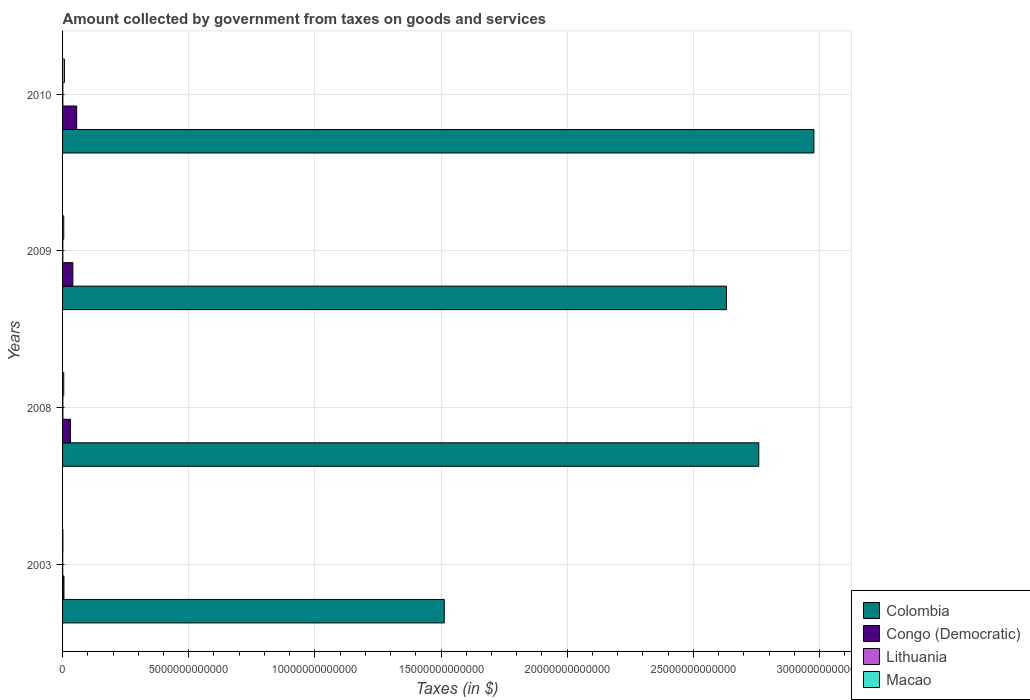Are the number of bars on each tick of the Y-axis equal?
Give a very brief answer. Yes. How many bars are there on the 3rd tick from the top?
Keep it short and to the point. 4. How many bars are there on the 2nd tick from the bottom?
Provide a succinct answer. 4. What is the label of the 1st group of bars from the top?
Provide a short and direct response. 2010. In how many cases, is the number of bars for a given year not equal to the number of legend labels?
Your answer should be compact. 0. What is the amount collected by government from taxes on goods and services in Colombia in 2010?
Offer a terse response. 2.98e+13. Across all years, what is the maximum amount collected by government from taxes on goods and services in Colombia?
Keep it short and to the point. 2.98e+13. Across all years, what is the minimum amount collected by government from taxes on goods and services in Colombia?
Your response must be concise. 1.51e+13. In which year was the amount collected by government from taxes on goods and services in Congo (Democratic) minimum?
Your answer should be compact. 2003. What is the total amount collected by government from taxes on goods and services in Lithuania in the graph?
Make the answer very short. 3.94e+1. What is the difference between the amount collected by government from taxes on goods and services in Congo (Democratic) in 2003 and that in 2010?
Offer a very short reply. -5.03e+11. What is the difference between the amount collected by government from taxes on goods and services in Colombia in 2010 and the amount collected by government from taxes on goods and services in Macao in 2008?
Provide a succinct answer. 2.97e+13. What is the average amount collected by government from taxes on goods and services in Macao per year?
Offer a very short reply. 4.46e+1. In the year 2010, what is the difference between the amount collected by government from taxes on goods and services in Lithuania and amount collected by government from taxes on goods and services in Congo (Democratic)?
Provide a short and direct response. -5.49e+11. What is the ratio of the amount collected by government from taxes on goods and services in Macao in 2003 to that in 2008?
Your response must be concise. 0.25. Is the difference between the amount collected by government from taxes on goods and services in Lithuania in 2008 and 2009 greater than the difference between the amount collected by government from taxes on goods and services in Congo (Democratic) in 2008 and 2009?
Offer a very short reply. Yes. What is the difference between the highest and the second highest amount collected by government from taxes on goods and services in Lithuania?
Offer a very short reply. 1.60e+09. What is the difference between the highest and the lowest amount collected by government from taxes on goods and services in Macao?
Ensure brevity in your answer.  6.15e+1. Is it the case that in every year, the sum of the amount collected by government from taxes on goods and services in Macao and amount collected by government from taxes on goods and services in Colombia is greater than the sum of amount collected by government from taxes on goods and services in Lithuania and amount collected by government from taxes on goods and services in Congo (Democratic)?
Make the answer very short. Yes. What does the 4th bar from the top in 2009 represents?
Make the answer very short. Colombia. Are all the bars in the graph horizontal?
Give a very brief answer. Yes. How many years are there in the graph?
Ensure brevity in your answer.  4. What is the difference between two consecutive major ticks on the X-axis?
Give a very brief answer. 5.00e+12. Does the graph contain any zero values?
Your answer should be compact. No. Does the graph contain grids?
Ensure brevity in your answer.  Yes. What is the title of the graph?
Give a very brief answer. Amount collected by government from taxes on goods and services. What is the label or title of the X-axis?
Provide a succinct answer. Taxes (in $). What is the label or title of the Y-axis?
Give a very brief answer. Years. What is the Taxes (in $) in Colombia in 2003?
Make the answer very short. 1.51e+13. What is the Taxes (in $) in Congo (Democratic) in 2003?
Give a very brief answer. 5.59e+1. What is the Taxes (in $) in Lithuania in 2003?
Make the answer very short. 6.27e+09. What is the Taxes (in $) of Macao in 2003?
Offer a terse response. 1.17e+1. What is the Taxes (in $) of Colombia in 2008?
Make the answer very short. 2.76e+13. What is the Taxes (in $) of Congo (Democratic) in 2008?
Keep it short and to the point. 3.13e+11. What is the Taxes (in $) in Lithuania in 2008?
Provide a short and direct response. 1.24e+1. What is the Taxes (in $) of Macao in 2008?
Give a very brief answer. 4.68e+1. What is the Taxes (in $) of Colombia in 2009?
Offer a terse response. 2.63e+13. What is the Taxes (in $) of Congo (Democratic) in 2009?
Your response must be concise. 4.07e+11. What is the Taxes (in $) of Lithuania in 2009?
Provide a short and direct response. 1.00e+1. What is the Taxes (in $) in Macao in 2009?
Your response must be concise. 4.67e+1. What is the Taxes (in $) of Colombia in 2010?
Offer a very short reply. 2.98e+13. What is the Taxes (in $) in Congo (Democratic) in 2010?
Your answer should be very brief. 5.59e+11. What is the Taxes (in $) of Lithuania in 2010?
Offer a very short reply. 1.08e+1. What is the Taxes (in $) of Macao in 2010?
Provide a succinct answer. 7.32e+1. Across all years, what is the maximum Taxes (in $) in Colombia?
Provide a short and direct response. 2.98e+13. Across all years, what is the maximum Taxes (in $) of Congo (Democratic)?
Offer a terse response. 5.59e+11. Across all years, what is the maximum Taxes (in $) of Lithuania?
Offer a very short reply. 1.24e+1. Across all years, what is the maximum Taxes (in $) of Macao?
Give a very brief answer. 7.32e+1. Across all years, what is the minimum Taxes (in $) in Colombia?
Make the answer very short. 1.51e+13. Across all years, what is the minimum Taxes (in $) in Congo (Democratic)?
Your answer should be very brief. 5.59e+1. Across all years, what is the minimum Taxes (in $) in Lithuania?
Give a very brief answer. 6.27e+09. Across all years, what is the minimum Taxes (in $) of Macao?
Ensure brevity in your answer.  1.17e+1. What is the total Taxes (in $) of Colombia in the graph?
Offer a very short reply. 9.88e+13. What is the total Taxes (in $) of Congo (Democratic) in the graph?
Make the answer very short. 1.34e+12. What is the total Taxes (in $) of Lithuania in the graph?
Your response must be concise. 3.94e+1. What is the total Taxes (in $) in Macao in the graph?
Provide a succinct answer. 1.78e+11. What is the difference between the Taxes (in $) of Colombia in 2003 and that in 2008?
Give a very brief answer. -1.25e+13. What is the difference between the Taxes (in $) of Congo (Democratic) in 2003 and that in 2008?
Give a very brief answer. -2.57e+11. What is the difference between the Taxes (in $) in Lithuania in 2003 and that in 2008?
Ensure brevity in your answer.  -6.09e+09. What is the difference between the Taxes (in $) in Macao in 2003 and that in 2008?
Your response must be concise. -3.51e+1. What is the difference between the Taxes (in $) in Colombia in 2003 and that in 2009?
Give a very brief answer. -1.12e+13. What is the difference between the Taxes (in $) in Congo (Democratic) in 2003 and that in 2009?
Offer a terse response. -3.51e+11. What is the difference between the Taxes (in $) in Lithuania in 2003 and that in 2009?
Keep it short and to the point. -3.77e+09. What is the difference between the Taxes (in $) in Macao in 2003 and that in 2009?
Offer a terse response. -3.50e+1. What is the difference between the Taxes (in $) in Colombia in 2003 and that in 2010?
Ensure brevity in your answer.  -1.47e+13. What is the difference between the Taxes (in $) in Congo (Democratic) in 2003 and that in 2010?
Your answer should be very brief. -5.03e+11. What is the difference between the Taxes (in $) in Lithuania in 2003 and that in 2010?
Offer a very short reply. -4.48e+09. What is the difference between the Taxes (in $) in Macao in 2003 and that in 2010?
Your response must be concise. -6.15e+1. What is the difference between the Taxes (in $) of Colombia in 2008 and that in 2009?
Keep it short and to the point. 1.28e+12. What is the difference between the Taxes (in $) in Congo (Democratic) in 2008 and that in 2009?
Provide a succinct answer. -9.42e+1. What is the difference between the Taxes (in $) in Lithuania in 2008 and that in 2009?
Make the answer very short. 2.31e+09. What is the difference between the Taxes (in $) in Macao in 2008 and that in 2009?
Offer a terse response. 8.05e+07. What is the difference between the Taxes (in $) in Colombia in 2008 and that in 2010?
Offer a terse response. -2.18e+12. What is the difference between the Taxes (in $) of Congo (Democratic) in 2008 and that in 2010?
Your answer should be compact. -2.46e+11. What is the difference between the Taxes (in $) in Lithuania in 2008 and that in 2010?
Your answer should be compact. 1.60e+09. What is the difference between the Taxes (in $) of Macao in 2008 and that in 2010?
Make the answer very short. -2.64e+1. What is the difference between the Taxes (in $) in Colombia in 2009 and that in 2010?
Provide a succinct answer. -3.47e+12. What is the difference between the Taxes (in $) of Congo (Democratic) in 2009 and that in 2010?
Provide a succinct answer. -1.52e+11. What is the difference between the Taxes (in $) in Lithuania in 2009 and that in 2010?
Make the answer very short. -7.11e+08. What is the difference between the Taxes (in $) in Macao in 2009 and that in 2010?
Provide a short and direct response. -2.64e+1. What is the difference between the Taxes (in $) of Colombia in 2003 and the Taxes (in $) of Congo (Democratic) in 2008?
Offer a terse response. 1.48e+13. What is the difference between the Taxes (in $) in Colombia in 2003 and the Taxes (in $) in Lithuania in 2008?
Provide a succinct answer. 1.51e+13. What is the difference between the Taxes (in $) in Colombia in 2003 and the Taxes (in $) in Macao in 2008?
Ensure brevity in your answer.  1.51e+13. What is the difference between the Taxes (in $) of Congo (Democratic) in 2003 and the Taxes (in $) of Lithuania in 2008?
Ensure brevity in your answer.  4.35e+1. What is the difference between the Taxes (in $) of Congo (Democratic) in 2003 and the Taxes (in $) of Macao in 2008?
Your answer should be very brief. 9.08e+09. What is the difference between the Taxes (in $) in Lithuania in 2003 and the Taxes (in $) in Macao in 2008?
Your response must be concise. -4.06e+1. What is the difference between the Taxes (in $) of Colombia in 2003 and the Taxes (in $) of Congo (Democratic) in 2009?
Provide a succinct answer. 1.47e+13. What is the difference between the Taxes (in $) in Colombia in 2003 and the Taxes (in $) in Lithuania in 2009?
Offer a very short reply. 1.51e+13. What is the difference between the Taxes (in $) in Colombia in 2003 and the Taxes (in $) in Macao in 2009?
Your answer should be compact. 1.51e+13. What is the difference between the Taxes (in $) of Congo (Democratic) in 2003 and the Taxes (in $) of Lithuania in 2009?
Ensure brevity in your answer.  4.59e+1. What is the difference between the Taxes (in $) in Congo (Democratic) in 2003 and the Taxes (in $) in Macao in 2009?
Ensure brevity in your answer.  9.16e+09. What is the difference between the Taxes (in $) of Lithuania in 2003 and the Taxes (in $) of Macao in 2009?
Make the answer very short. -4.05e+1. What is the difference between the Taxes (in $) of Colombia in 2003 and the Taxes (in $) of Congo (Democratic) in 2010?
Make the answer very short. 1.46e+13. What is the difference between the Taxes (in $) of Colombia in 2003 and the Taxes (in $) of Lithuania in 2010?
Your response must be concise. 1.51e+13. What is the difference between the Taxes (in $) of Colombia in 2003 and the Taxes (in $) of Macao in 2010?
Keep it short and to the point. 1.51e+13. What is the difference between the Taxes (in $) in Congo (Democratic) in 2003 and the Taxes (in $) in Lithuania in 2010?
Offer a very short reply. 4.52e+1. What is the difference between the Taxes (in $) in Congo (Democratic) in 2003 and the Taxes (in $) in Macao in 2010?
Offer a terse response. -1.73e+1. What is the difference between the Taxes (in $) of Lithuania in 2003 and the Taxes (in $) of Macao in 2010?
Ensure brevity in your answer.  -6.69e+1. What is the difference between the Taxes (in $) in Colombia in 2008 and the Taxes (in $) in Congo (Democratic) in 2009?
Give a very brief answer. 2.72e+13. What is the difference between the Taxes (in $) of Colombia in 2008 and the Taxes (in $) of Lithuania in 2009?
Give a very brief answer. 2.76e+13. What is the difference between the Taxes (in $) of Colombia in 2008 and the Taxes (in $) of Macao in 2009?
Your answer should be very brief. 2.75e+13. What is the difference between the Taxes (in $) of Congo (Democratic) in 2008 and the Taxes (in $) of Lithuania in 2009?
Your answer should be very brief. 3.03e+11. What is the difference between the Taxes (in $) of Congo (Democratic) in 2008 and the Taxes (in $) of Macao in 2009?
Ensure brevity in your answer.  2.66e+11. What is the difference between the Taxes (in $) in Lithuania in 2008 and the Taxes (in $) in Macao in 2009?
Offer a terse response. -3.44e+1. What is the difference between the Taxes (in $) in Colombia in 2008 and the Taxes (in $) in Congo (Democratic) in 2010?
Provide a short and direct response. 2.70e+13. What is the difference between the Taxes (in $) of Colombia in 2008 and the Taxes (in $) of Lithuania in 2010?
Provide a short and direct response. 2.76e+13. What is the difference between the Taxes (in $) of Colombia in 2008 and the Taxes (in $) of Macao in 2010?
Make the answer very short. 2.75e+13. What is the difference between the Taxes (in $) in Congo (Democratic) in 2008 and the Taxes (in $) in Lithuania in 2010?
Provide a succinct answer. 3.02e+11. What is the difference between the Taxes (in $) of Congo (Democratic) in 2008 and the Taxes (in $) of Macao in 2010?
Provide a short and direct response. 2.40e+11. What is the difference between the Taxes (in $) in Lithuania in 2008 and the Taxes (in $) in Macao in 2010?
Provide a short and direct response. -6.08e+1. What is the difference between the Taxes (in $) in Colombia in 2009 and the Taxes (in $) in Congo (Democratic) in 2010?
Your answer should be very brief. 2.58e+13. What is the difference between the Taxes (in $) in Colombia in 2009 and the Taxes (in $) in Lithuania in 2010?
Provide a short and direct response. 2.63e+13. What is the difference between the Taxes (in $) of Colombia in 2009 and the Taxes (in $) of Macao in 2010?
Provide a succinct answer. 2.62e+13. What is the difference between the Taxes (in $) in Congo (Democratic) in 2009 and the Taxes (in $) in Lithuania in 2010?
Your response must be concise. 3.96e+11. What is the difference between the Taxes (in $) of Congo (Democratic) in 2009 and the Taxes (in $) of Macao in 2010?
Your answer should be compact. 3.34e+11. What is the difference between the Taxes (in $) of Lithuania in 2009 and the Taxes (in $) of Macao in 2010?
Offer a terse response. -6.31e+1. What is the average Taxes (in $) of Colombia per year?
Your answer should be compact. 2.47e+13. What is the average Taxes (in $) of Congo (Democratic) per year?
Your response must be concise. 3.34e+11. What is the average Taxes (in $) of Lithuania per year?
Ensure brevity in your answer.  9.86e+09. What is the average Taxes (in $) of Macao per year?
Your response must be concise. 4.46e+1. In the year 2003, what is the difference between the Taxes (in $) of Colombia and Taxes (in $) of Congo (Democratic)?
Provide a succinct answer. 1.51e+13. In the year 2003, what is the difference between the Taxes (in $) of Colombia and Taxes (in $) of Lithuania?
Make the answer very short. 1.51e+13. In the year 2003, what is the difference between the Taxes (in $) in Colombia and Taxes (in $) in Macao?
Make the answer very short. 1.51e+13. In the year 2003, what is the difference between the Taxes (in $) of Congo (Democratic) and Taxes (in $) of Lithuania?
Ensure brevity in your answer.  4.96e+1. In the year 2003, what is the difference between the Taxes (in $) in Congo (Democratic) and Taxes (in $) in Macao?
Provide a short and direct response. 4.42e+1. In the year 2003, what is the difference between the Taxes (in $) of Lithuania and Taxes (in $) of Macao?
Your response must be concise. -5.46e+09. In the year 2008, what is the difference between the Taxes (in $) of Colombia and Taxes (in $) of Congo (Democratic)?
Your answer should be very brief. 2.73e+13. In the year 2008, what is the difference between the Taxes (in $) in Colombia and Taxes (in $) in Lithuania?
Offer a very short reply. 2.76e+13. In the year 2008, what is the difference between the Taxes (in $) in Colombia and Taxes (in $) in Macao?
Keep it short and to the point. 2.75e+13. In the year 2008, what is the difference between the Taxes (in $) of Congo (Democratic) and Taxes (in $) of Lithuania?
Provide a succinct answer. 3.01e+11. In the year 2008, what is the difference between the Taxes (in $) in Congo (Democratic) and Taxes (in $) in Macao?
Your answer should be very brief. 2.66e+11. In the year 2008, what is the difference between the Taxes (in $) of Lithuania and Taxes (in $) of Macao?
Keep it short and to the point. -3.45e+1. In the year 2009, what is the difference between the Taxes (in $) in Colombia and Taxes (in $) in Congo (Democratic)?
Offer a very short reply. 2.59e+13. In the year 2009, what is the difference between the Taxes (in $) of Colombia and Taxes (in $) of Lithuania?
Give a very brief answer. 2.63e+13. In the year 2009, what is the difference between the Taxes (in $) of Colombia and Taxes (in $) of Macao?
Provide a short and direct response. 2.63e+13. In the year 2009, what is the difference between the Taxes (in $) of Congo (Democratic) and Taxes (in $) of Lithuania?
Make the answer very short. 3.97e+11. In the year 2009, what is the difference between the Taxes (in $) in Congo (Democratic) and Taxes (in $) in Macao?
Your response must be concise. 3.60e+11. In the year 2009, what is the difference between the Taxes (in $) in Lithuania and Taxes (in $) in Macao?
Offer a very short reply. -3.67e+1. In the year 2010, what is the difference between the Taxes (in $) in Colombia and Taxes (in $) in Congo (Democratic)?
Keep it short and to the point. 2.92e+13. In the year 2010, what is the difference between the Taxes (in $) of Colombia and Taxes (in $) of Lithuania?
Ensure brevity in your answer.  2.98e+13. In the year 2010, what is the difference between the Taxes (in $) in Colombia and Taxes (in $) in Macao?
Your answer should be very brief. 2.97e+13. In the year 2010, what is the difference between the Taxes (in $) of Congo (Democratic) and Taxes (in $) of Lithuania?
Your answer should be very brief. 5.49e+11. In the year 2010, what is the difference between the Taxes (in $) in Congo (Democratic) and Taxes (in $) in Macao?
Your answer should be compact. 4.86e+11. In the year 2010, what is the difference between the Taxes (in $) in Lithuania and Taxes (in $) in Macao?
Offer a very short reply. -6.24e+1. What is the ratio of the Taxes (in $) in Colombia in 2003 to that in 2008?
Your answer should be compact. 0.55. What is the ratio of the Taxes (in $) in Congo (Democratic) in 2003 to that in 2008?
Ensure brevity in your answer.  0.18. What is the ratio of the Taxes (in $) of Lithuania in 2003 to that in 2008?
Provide a succinct answer. 0.51. What is the ratio of the Taxes (in $) of Macao in 2003 to that in 2008?
Offer a very short reply. 0.25. What is the ratio of the Taxes (in $) in Colombia in 2003 to that in 2009?
Provide a succinct answer. 0.57. What is the ratio of the Taxes (in $) in Congo (Democratic) in 2003 to that in 2009?
Your answer should be very brief. 0.14. What is the ratio of the Taxes (in $) in Lithuania in 2003 to that in 2009?
Ensure brevity in your answer.  0.62. What is the ratio of the Taxes (in $) in Macao in 2003 to that in 2009?
Offer a very short reply. 0.25. What is the ratio of the Taxes (in $) in Colombia in 2003 to that in 2010?
Give a very brief answer. 0.51. What is the ratio of the Taxes (in $) in Lithuania in 2003 to that in 2010?
Your answer should be compact. 0.58. What is the ratio of the Taxes (in $) of Macao in 2003 to that in 2010?
Offer a terse response. 0.16. What is the ratio of the Taxes (in $) of Colombia in 2008 to that in 2009?
Offer a terse response. 1.05. What is the ratio of the Taxes (in $) in Congo (Democratic) in 2008 to that in 2009?
Keep it short and to the point. 0.77. What is the ratio of the Taxes (in $) of Lithuania in 2008 to that in 2009?
Provide a short and direct response. 1.23. What is the ratio of the Taxes (in $) of Colombia in 2008 to that in 2010?
Your answer should be very brief. 0.93. What is the ratio of the Taxes (in $) in Congo (Democratic) in 2008 to that in 2010?
Make the answer very short. 0.56. What is the ratio of the Taxes (in $) of Lithuania in 2008 to that in 2010?
Give a very brief answer. 1.15. What is the ratio of the Taxes (in $) in Macao in 2008 to that in 2010?
Your answer should be very brief. 0.64. What is the ratio of the Taxes (in $) of Colombia in 2009 to that in 2010?
Offer a very short reply. 0.88. What is the ratio of the Taxes (in $) of Congo (Democratic) in 2009 to that in 2010?
Offer a terse response. 0.73. What is the ratio of the Taxes (in $) of Lithuania in 2009 to that in 2010?
Offer a very short reply. 0.93. What is the ratio of the Taxes (in $) of Macao in 2009 to that in 2010?
Your response must be concise. 0.64. What is the difference between the highest and the second highest Taxes (in $) in Colombia?
Keep it short and to the point. 2.18e+12. What is the difference between the highest and the second highest Taxes (in $) in Congo (Democratic)?
Keep it short and to the point. 1.52e+11. What is the difference between the highest and the second highest Taxes (in $) of Lithuania?
Keep it short and to the point. 1.60e+09. What is the difference between the highest and the second highest Taxes (in $) of Macao?
Keep it short and to the point. 2.64e+1. What is the difference between the highest and the lowest Taxes (in $) in Colombia?
Ensure brevity in your answer.  1.47e+13. What is the difference between the highest and the lowest Taxes (in $) of Congo (Democratic)?
Your answer should be compact. 5.03e+11. What is the difference between the highest and the lowest Taxes (in $) of Lithuania?
Your response must be concise. 6.09e+09. What is the difference between the highest and the lowest Taxes (in $) of Macao?
Your answer should be very brief. 6.15e+1. 